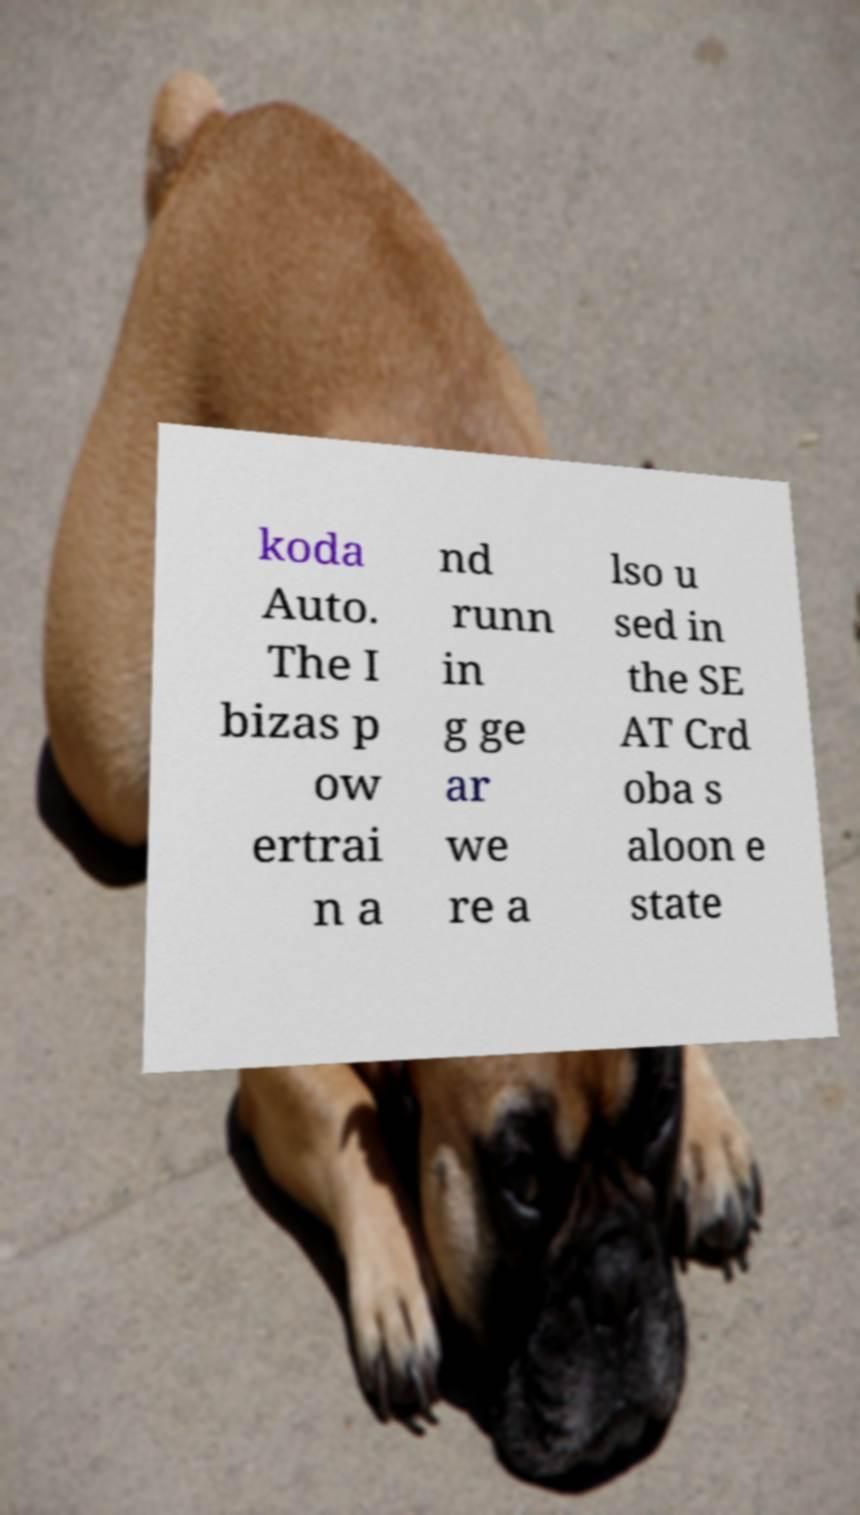For documentation purposes, I need the text within this image transcribed. Could you provide that? koda Auto. The I bizas p ow ertrai n a nd runn in g ge ar we re a lso u sed in the SE AT Crd oba s aloon e state 